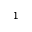<formula> <loc_0><loc_0><loc_500><loc_500>^ { 1 }</formula> 